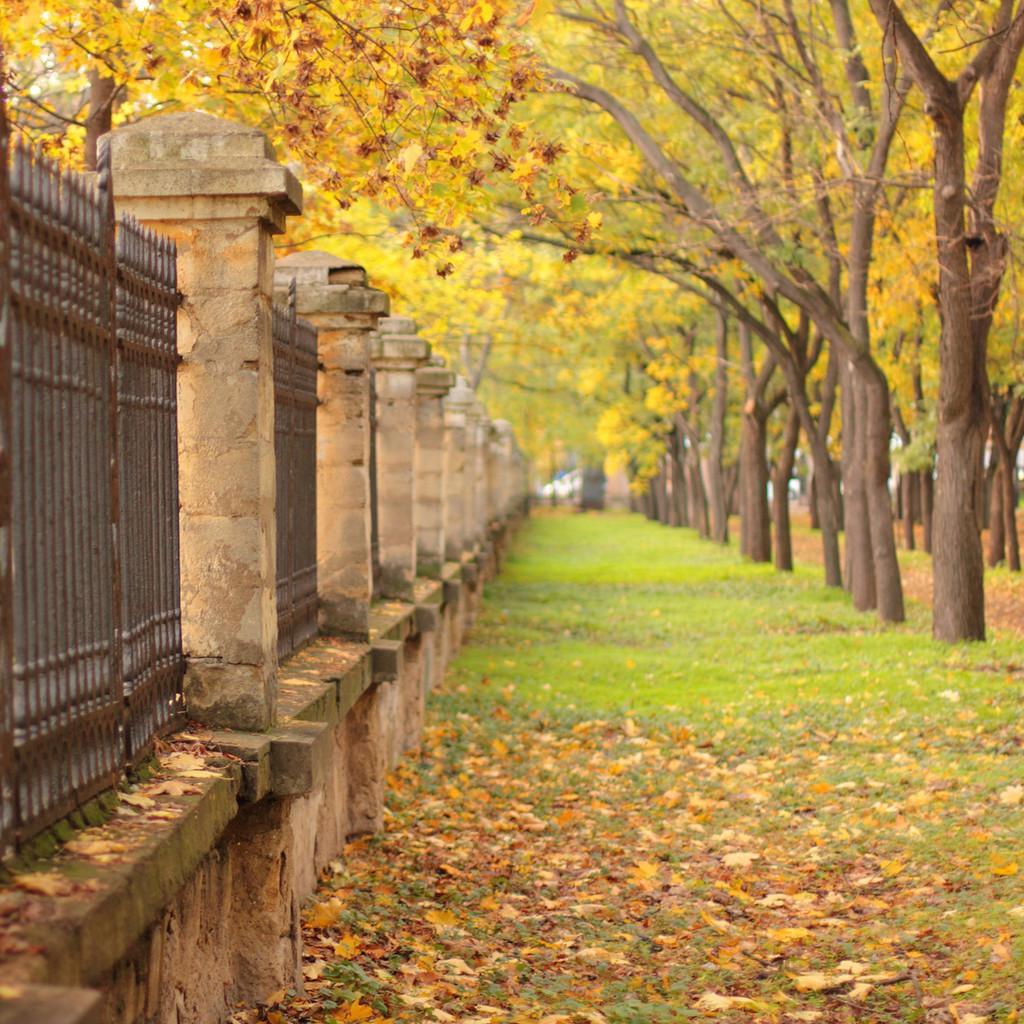Describe this image in one or two sentences. In this picture we can see some fencing and a wall on the left side. Some grass and leaves are visible on the ground. There are few trees on the right side. 